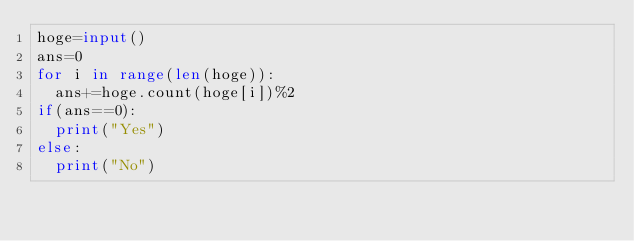Convert code to text. <code><loc_0><loc_0><loc_500><loc_500><_Python_>hoge=input()
ans=0
for i in range(len(hoge)):
  ans+=hoge.count(hoge[i])%2
if(ans==0):
  print("Yes")
else:
  print("No")</code> 